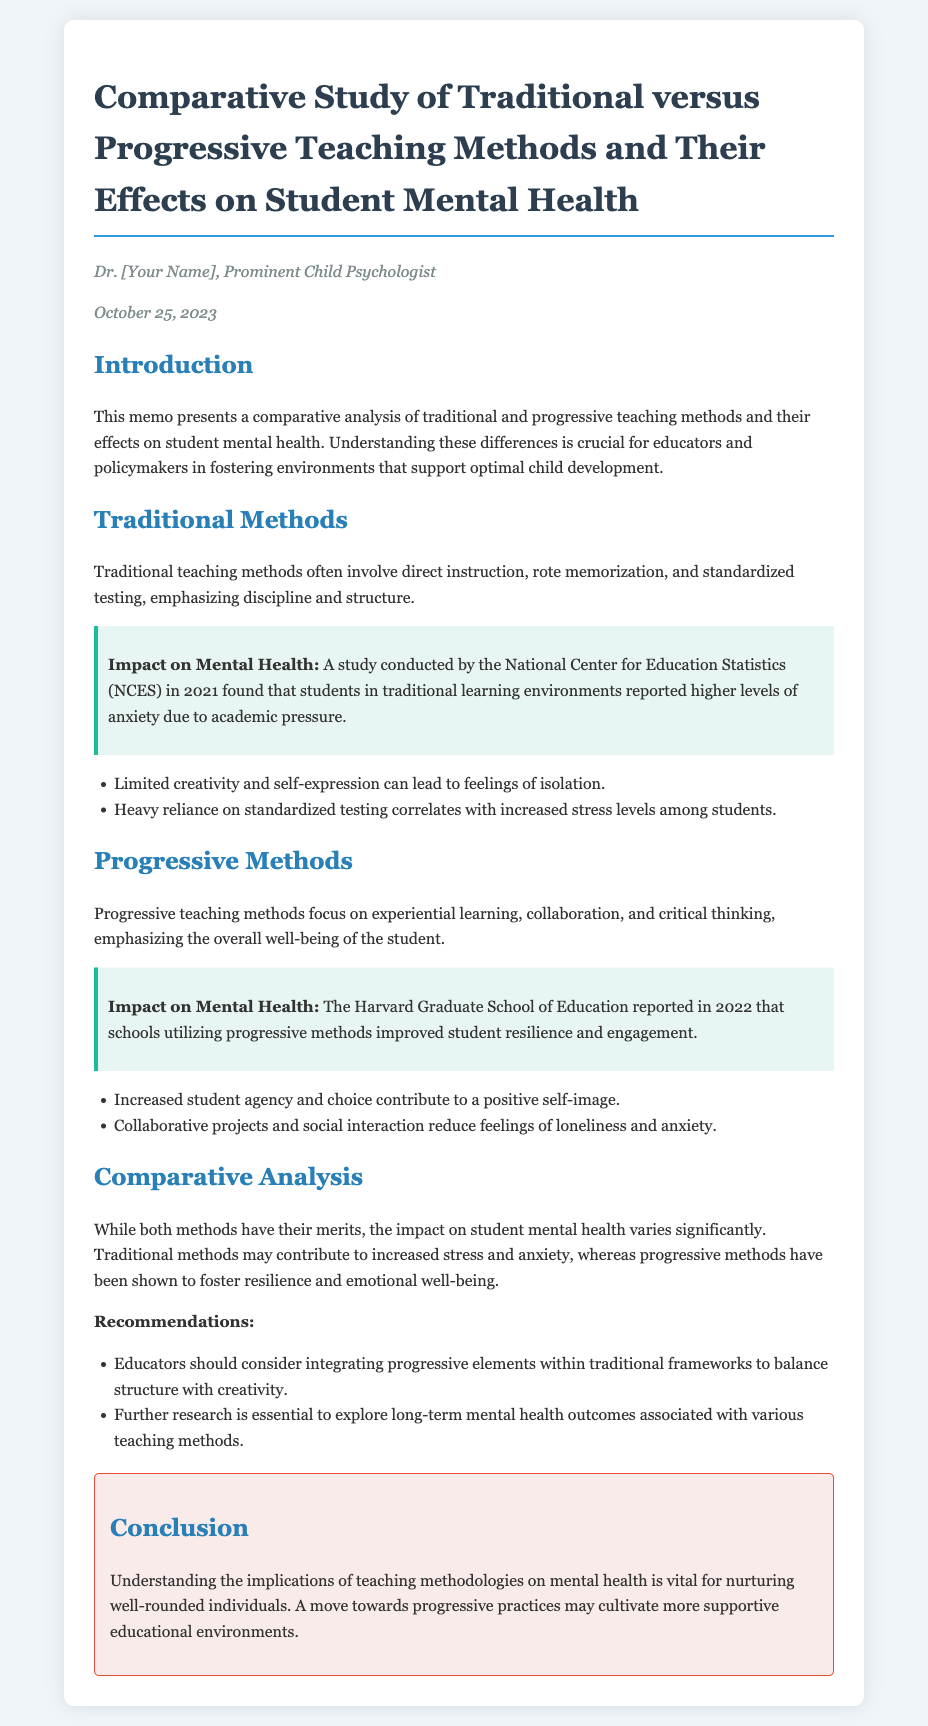What is the title of the memo? The title is provided in the header section of the document.
Answer: Comparative Study of Traditional versus Progressive Teaching Methods and Their Effects on Student Mental Health Who authored the memo? The author is mentioned right below the title in the document.
Answer: Dr. [Your Name] When was the memo dated? The date is included in the introductory section of the memo.
Answer: October 25, 2023 What organization conducted a study on traditional methods? The specific organization is referenced in the section discussing traditional methods.
Answer: National Center for Education Statistics (NCES) What was a significant finding about progressive methods? This finding is highlighted in the section on progressive methods.
Answer: Improved student resilience and engagement What is a recommended action for educators? The recommendations are listed towards the end of the comparative analysis section.
Answer: Integrating progressive elements within traditional frameworks How do traditional methods impact mental health according to the memo? This is summarized in the analysis of traditional methods in the document.
Answer: Increased anxiety due to academic pressure What is the main focus of progressive methods? The focus is outlined in the section dedicated to progressive teaching methods.
Answer: Experiential learning and collaboration What type of educational environment does the conclusion suggest? The conclusion summarizes the vision for future educational practices.
Answer: Supportive educational environments 